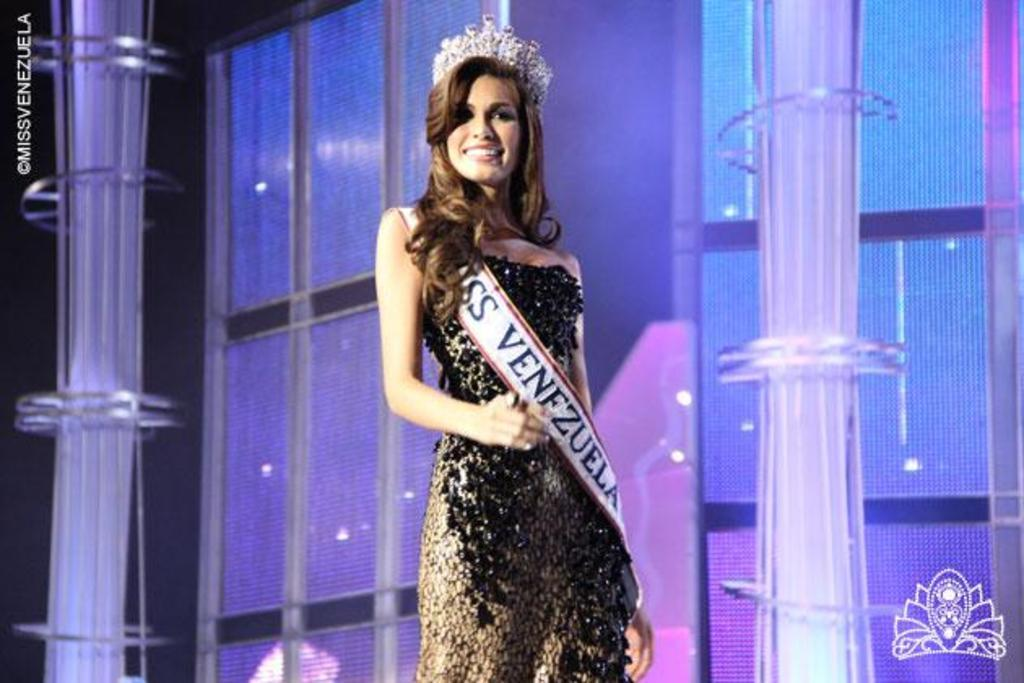Who or what is in the image? There is a person in the image. What is the person standing in front of? The person is standing in front of a glass wall. What is the person wearing? The person is wearing clothes and a crown. What can be seen on the sides of the image? There are poles on both the left and right sides of the image. Can you see any frogs jumping around the person in the image? No, there are no frogs present in the image. Is there any smoke visible in the image? No, there is no smoke visible in the image. 